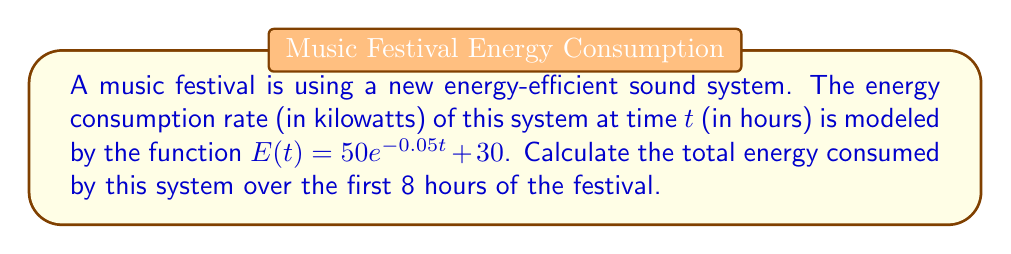Help me with this question. To solve this problem, we need to integrate the energy consumption rate function over the given time interval. Here's a step-by-step approach:

1) The total energy consumed is the integral of the energy consumption rate function from $t=0$ to $t=8$:

   $$\text{Total Energy} = \int_0^8 E(t) dt = \int_0^8 (50e^{-0.05t} + 30) dt$$

2) Let's split this integral into two parts:

   $$\int_0^8 50e^{-0.05t} dt + \int_0^8 30 dt$$

3) For the first part, we can use the substitution method:
   Let $u = -0.05t$, then $du = -0.05dt$ or $dt = -20du$

   $$50 \int_0^8 e^{-0.05t} dt = -1000 \int_0^{-0.4} e^u du = -1000 [e^u]_0^{-0.4}$$
   $$= -1000 (e^{-0.4} - e^0) = -1000 (e^{-0.4} - 1)$$

4) The second part is straightforward:

   $$30 \int_0^8 dt = 30t|_0^8 = 240$$

5) Adding the results from steps 3 and 4:

   $$\text{Total Energy} = -1000 (e^{-0.4} - 1) + 240$$

6) Evaluating this expression:

   $$\text{Total Energy} \approx 829.99 + 240 = 1069.99 \text{ kilowatt-hours (kWh)}$$
Answer: The total energy consumed by the sound system over the first 8 hours of the festival is approximately 1070 kWh. 